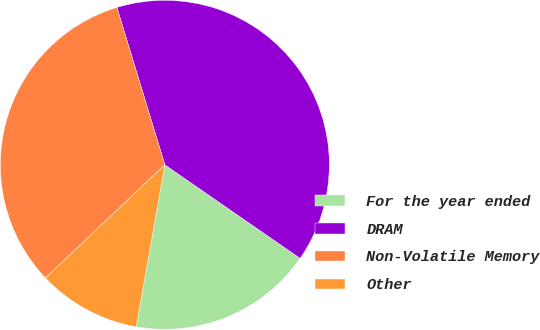<chart> <loc_0><loc_0><loc_500><loc_500><pie_chart><fcel>For the year ended<fcel>DRAM<fcel>Non-Volatile Memory<fcel>Other<nl><fcel>18.16%<fcel>39.34%<fcel>32.37%<fcel>10.13%<nl></chart> 